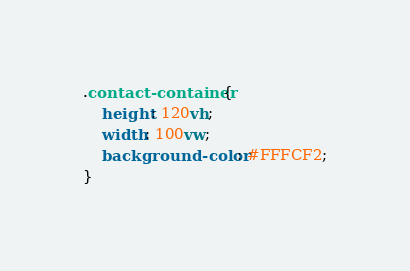Convert code to text. <code><loc_0><loc_0><loc_500><loc_500><_CSS_>.contact-container{
    height: 120vh;
    width: 100vw;
    background-color: #FFFCF2;
}</code> 